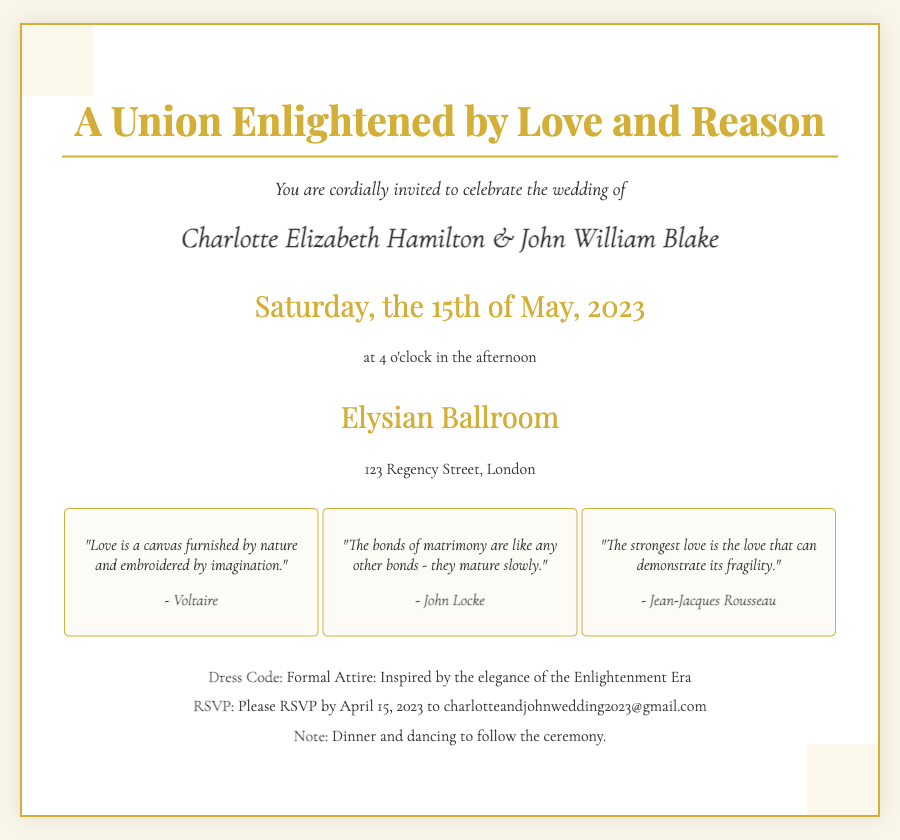What date is the wedding? The wedding date is explicitly stated within the invitation.
Answer: Saturday, the 15th of May, 2023 Who are the couple getting married? The names of the bride and groom are highlighted prominently in the invitation.
Answer: Charlotte Elizabeth Hamilton & John William Blake What is the venue of the wedding? The invitation specifies the location of the ceremony.
Answer: Elysian Ballroom What is the dress code? The dress code is mentioned under the additional information section of the invitation.
Answer: Formal Attire: Inspired by the elegance of the Enlightenment Era Which Enlightenment thinker is quoted about love as a canvas? The different quotes listed within the invitation provide insight into the contributors.
Answer: Voltaire What time does the wedding ceremony start? The invitation includes the time of the ceremony clearly in the schedule.
Answer: 4 o'clock in the afternoon How should guests RSVP? Details regarding RSVP are typically included at the end of invitations.
Answer: RSVP by April 15, 2023 to charlotteandjohnwedding2023@gmail.com What is the theme of the wedding invitation? The invitation reflects its theme through its title and visual motifs.
Answer: Enlightenment Era Aesthetic 